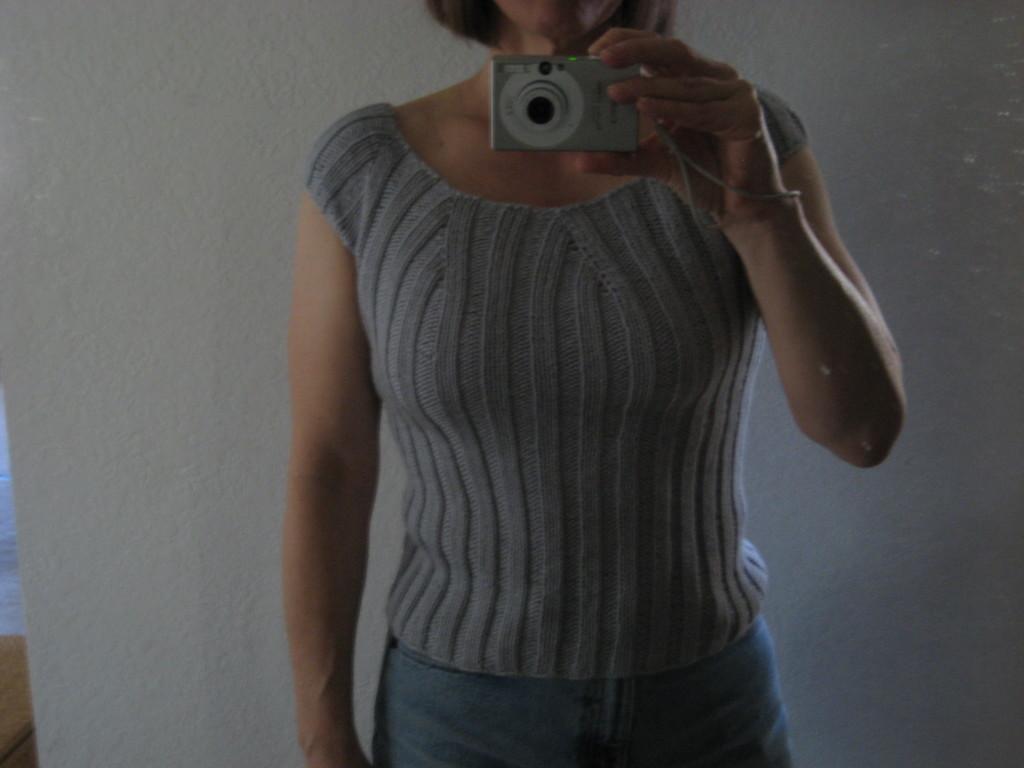Please provide a concise description of this image. Here we can see a woman standing with a camera in her hand 